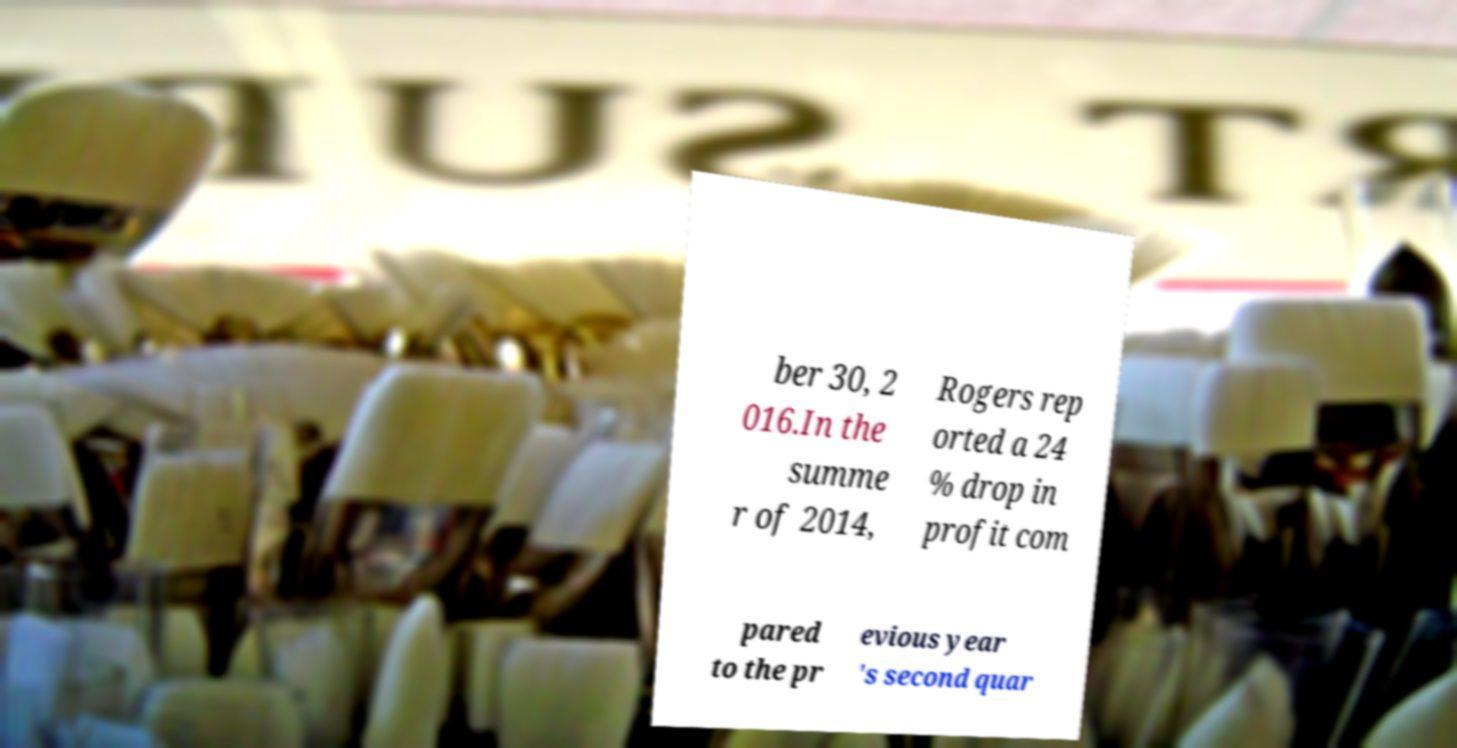Could you extract and type out the text from this image? ber 30, 2 016.In the summe r of 2014, Rogers rep orted a 24 % drop in profit com pared to the pr evious year 's second quar 